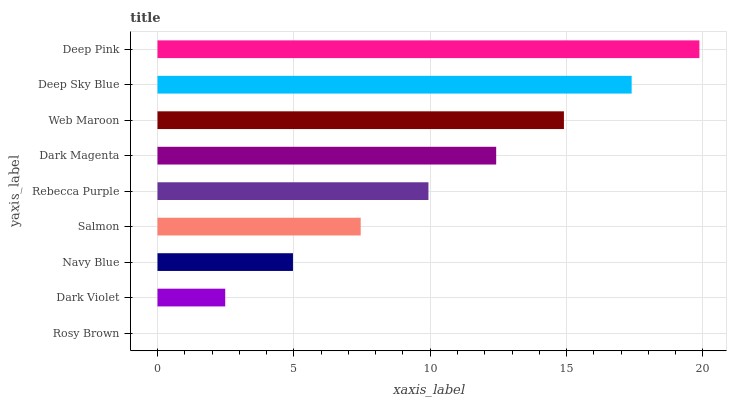Is Rosy Brown the minimum?
Answer yes or no. Yes. Is Deep Pink the maximum?
Answer yes or no. Yes. Is Dark Violet the minimum?
Answer yes or no. No. Is Dark Violet the maximum?
Answer yes or no. No. Is Dark Violet greater than Rosy Brown?
Answer yes or no. Yes. Is Rosy Brown less than Dark Violet?
Answer yes or no. Yes. Is Rosy Brown greater than Dark Violet?
Answer yes or no. No. Is Dark Violet less than Rosy Brown?
Answer yes or no. No. Is Rebecca Purple the high median?
Answer yes or no. Yes. Is Rebecca Purple the low median?
Answer yes or no. Yes. Is Web Maroon the high median?
Answer yes or no. No. Is Web Maroon the low median?
Answer yes or no. No. 